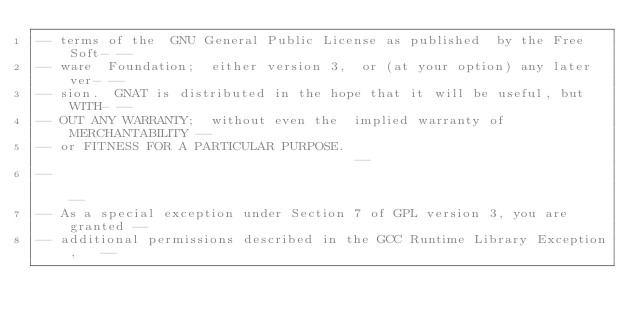Convert code to text. <code><loc_0><loc_0><loc_500><loc_500><_Ada_>-- terms of the  GNU General Public License as published  by the Free Soft- --
-- ware  Foundation;  either version 3,  or (at your option) any later ver- --
-- sion.  GNAT is distributed in the hope that it will be useful, but WITH- --
-- OUT ANY WARRANTY;  without even the  implied warranty of MERCHANTABILITY --
-- or FITNESS FOR A PARTICULAR PURPOSE.                                     --
--                                                                          --
-- As a special exception under Section 7 of GPL version 3, you are granted --
-- additional permissions described in the GCC Runtime Library Exception,   --</code> 